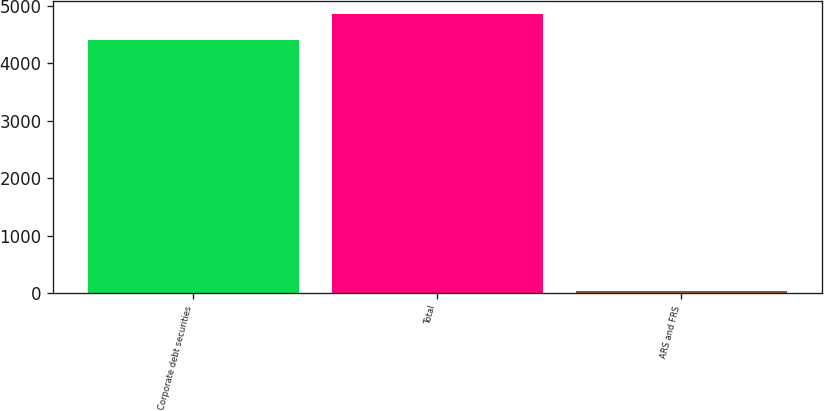<chart> <loc_0><loc_0><loc_500><loc_500><bar_chart><fcel>Corporate debt securities<fcel>Total<fcel>ARS and FRS<nl><fcel>4401<fcel>4851.3<fcel>29<nl></chart> 